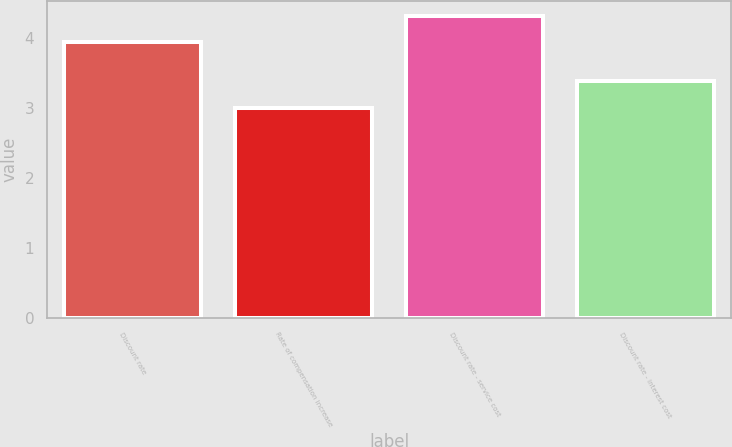Convert chart to OTSL. <chart><loc_0><loc_0><loc_500><loc_500><bar_chart><fcel>Discount rate<fcel>Rate of compensation increase<fcel>Discount rate - service cost<fcel>Discount rate - interest cost<nl><fcel>3.95<fcel>3<fcel>4.32<fcel>3.39<nl></chart> 